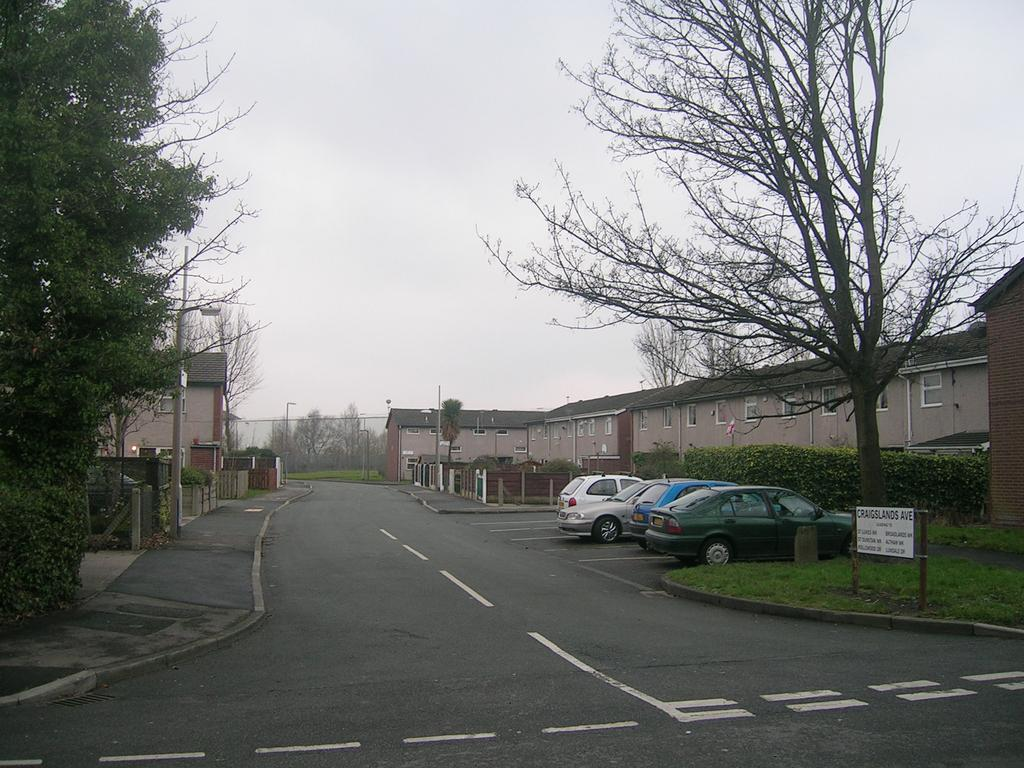What type of vehicles can be seen on the road in the image? There are cars on the road in the image. What type of path is present for pedestrians? There are footpaths in the image. What are the poles used for in the image? The poles in the image are likely used for streetlights or other utilities. What is the name board used for in the image? The name board in the image is likely used for indicating the name of a street or location. What type of structures can be seen with windows in the image? There are buildings with windows in the image. What type of vegetation is present in the image? There is grass and trees in the image. What type of barrier is present in the image? There are fences in the image. What can be seen in the background of the image? The sky is visible in the background of the image. Can you see the lake in the image? There is no lake present in the image. Is there any blood visible in the image? There is no blood visible in the image. 